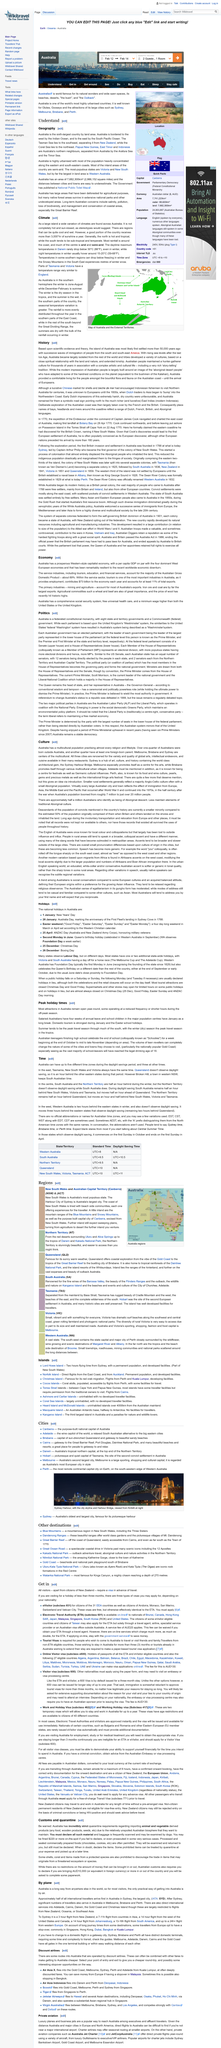Give some essential details in this illustration. The Tasman Sea separates Australia from New Zealand, marking the boundary between the two nations. Australia is the sixth-largest country by land area. Yes, the fact that Australia was most likely first settled more than 50,000 years ago is a part of history. Australia became largely isolated from the rest of the world. Yes, there were successive waves of immigration to Australia. 